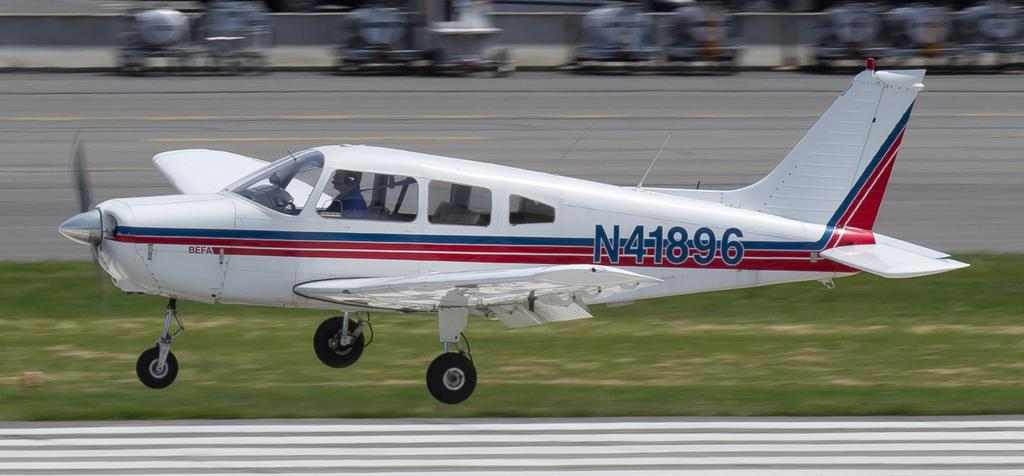What is the main subject of the picture? The main subject of the picture is a plane. What can be seen inside the plane? A human is sitting in the plane. Are there any markings or text on the plane? Yes, there is text on the plane. What type of surface is visible on the ground? There is grass on the ground. How would you describe the background of the image? The background of the image is blurry. What type of bomb can be seen in the mouth of the human sitting in the plane? There is no bomb or mouth visible in the image; it only shows a plane with a human sitting inside and text on the plane. 